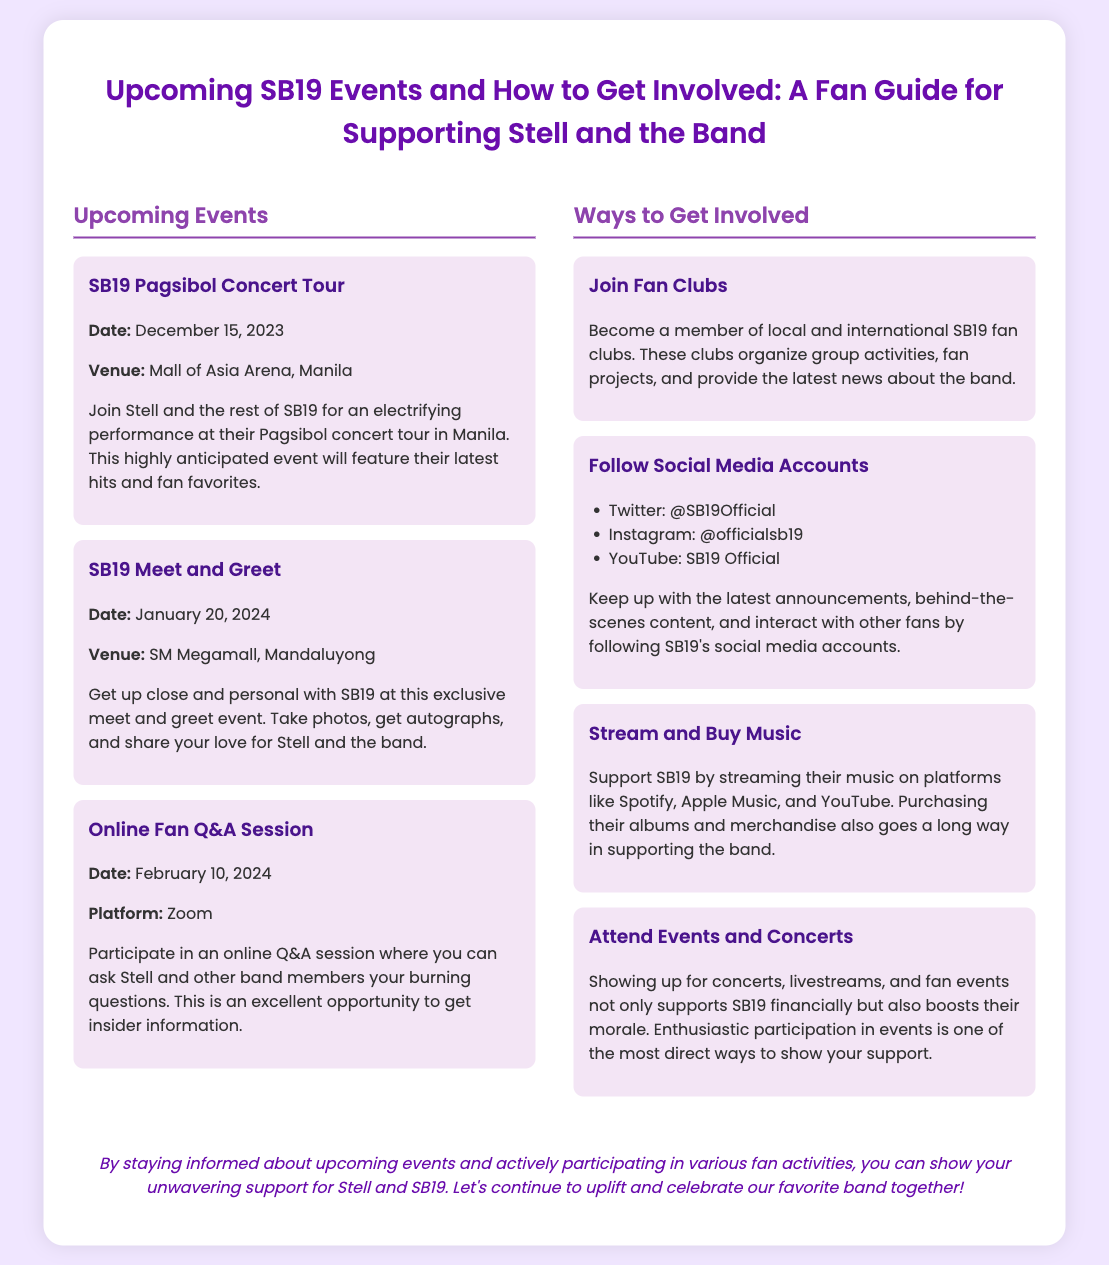What is the date of the SB19 Pagsibol Concert Tour? The document states that the SB19 Pagsibol Concert Tour is scheduled for December 15, 2023.
Answer: December 15, 2023 Where will the SB19 Meet and Greet take place? According to the document, the SB19 Meet and Greet will be held at SM Megamall in Mandaluyong.
Answer: SM Megamall, Mandaluyong What online platform will host the Fan Q&A Session? The document mentions that the Online Fan Q&A Session will take place on Zoom.
Answer: Zoom What is one way to support SB19 mentioned in the document? The document lists several methods, one being to stream and buy their music.
Answer: Stream and buy music What is the title of the presentation slide? The title, as stated in the document, is "Upcoming SB19 Events and How to Get Involved: A Fan Guide for Supporting Stell and the Band."
Answer: Upcoming SB19 Events and How to Get Involved: A Fan Guide for Supporting Stell and the Band How can fans participate in organized activities? The document explains that fans can join local and international SB19 fan clubs to participate in activities.
Answer: Join fan clubs What is the purpose of attending events and concerts according to the document? The document indicates that attending events supports SB19 financially and boosts their morale.
Answer: Supports SB19 financially and boosts morale When is the next upcoming SB19 event after the concert? The document lists the SB19 Meet and Greet as the next event after the concert, scheduled for January 20, 2024.
Answer: January 20, 2024 